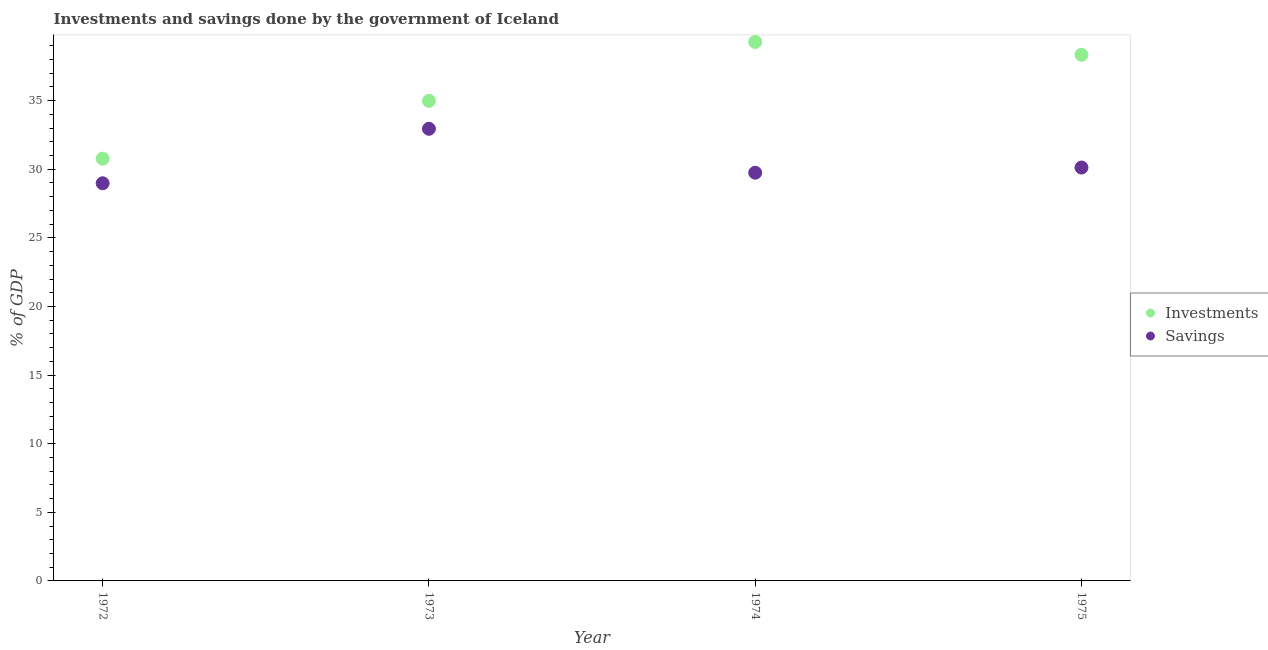Is the number of dotlines equal to the number of legend labels?
Your answer should be compact. Yes. What is the investments of government in 1974?
Provide a succinct answer. 39.28. Across all years, what is the maximum investments of government?
Ensure brevity in your answer.  39.28. Across all years, what is the minimum savings of government?
Offer a terse response. 28.98. In which year was the investments of government maximum?
Provide a succinct answer. 1974. In which year was the investments of government minimum?
Your response must be concise. 1972. What is the total savings of government in the graph?
Offer a terse response. 121.8. What is the difference between the investments of government in 1972 and that in 1973?
Provide a succinct answer. -4.21. What is the difference between the investments of government in 1975 and the savings of government in 1972?
Your answer should be compact. 9.36. What is the average savings of government per year?
Ensure brevity in your answer.  30.45. In the year 1974, what is the difference between the savings of government and investments of government?
Your response must be concise. -9.53. In how many years, is the savings of government greater than 6 %?
Your answer should be very brief. 4. What is the ratio of the investments of government in 1973 to that in 1974?
Give a very brief answer. 0.89. What is the difference between the highest and the second highest savings of government?
Keep it short and to the point. 2.82. What is the difference between the highest and the lowest investments of government?
Ensure brevity in your answer.  8.51. Is the sum of the investments of government in 1973 and 1975 greater than the maximum savings of government across all years?
Offer a terse response. Yes. Is the investments of government strictly greater than the savings of government over the years?
Your response must be concise. Yes. Is the investments of government strictly less than the savings of government over the years?
Make the answer very short. No. How many dotlines are there?
Your answer should be compact. 2. How many years are there in the graph?
Your answer should be compact. 4. Are the values on the major ticks of Y-axis written in scientific E-notation?
Your response must be concise. No. Does the graph contain any zero values?
Offer a very short reply. No. How many legend labels are there?
Your response must be concise. 2. What is the title of the graph?
Your response must be concise. Investments and savings done by the government of Iceland. What is the label or title of the Y-axis?
Keep it short and to the point. % of GDP. What is the % of GDP in Investments in 1972?
Offer a terse response. 30.77. What is the % of GDP in Savings in 1972?
Offer a terse response. 28.98. What is the % of GDP in Investments in 1973?
Give a very brief answer. 34.98. What is the % of GDP in Savings in 1973?
Keep it short and to the point. 32.95. What is the % of GDP in Investments in 1974?
Ensure brevity in your answer.  39.28. What is the % of GDP of Savings in 1974?
Your answer should be very brief. 29.75. What is the % of GDP of Investments in 1975?
Offer a very short reply. 38.34. What is the % of GDP of Savings in 1975?
Make the answer very short. 30.12. Across all years, what is the maximum % of GDP of Investments?
Your answer should be compact. 39.28. Across all years, what is the maximum % of GDP in Savings?
Offer a terse response. 32.95. Across all years, what is the minimum % of GDP in Investments?
Keep it short and to the point. 30.77. Across all years, what is the minimum % of GDP of Savings?
Offer a very short reply. 28.98. What is the total % of GDP of Investments in the graph?
Offer a very short reply. 143.37. What is the total % of GDP of Savings in the graph?
Keep it short and to the point. 121.8. What is the difference between the % of GDP in Investments in 1972 and that in 1973?
Your response must be concise. -4.21. What is the difference between the % of GDP in Savings in 1972 and that in 1973?
Give a very brief answer. -3.97. What is the difference between the % of GDP in Investments in 1972 and that in 1974?
Keep it short and to the point. -8.51. What is the difference between the % of GDP of Savings in 1972 and that in 1974?
Offer a very short reply. -0.77. What is the difference between the % of GDP in Investments in 1972 and that in 1975?
Keep it short and to the point. -7.57. What is the difference between the % of GDP of Savings in 1972 and that in 1975?
Make the answer very short. -1.15. What is the difference between the % of GDP of Investments in 1973 and that in 1974?
Your response must be concise. -4.29. What is the difference between the % of GDP in Savings in 1973 and that in 1974?
Offer a very short reply. 3.2. What is the difference between the % of GDP in Investments in 1973 and that in 1975?
Your answer should be compact. -3.36. What is the difference between the % of GDP in Savings in 1973 and that in 1975?
Your answer should be compact. 2.82. What is the difference between the % of GDP in Investments in 1974 and that in 1975?
Your response must be concise. 0.94. What is the difference between the % of GDP of Savings in 1974 and that in 1975?
Make the answer very short. -0.38. What is the difference between the % of GDP in Investments in 1972 and the % of GDP in Savings in 1973?
Offer a terse response. -2.18. What is the difference between the % of GDP in Investments in 1972 and the % of GDP in Savings in 1974?
Provide a succinct answer. 1.02. What is the difference between the % of GDP in Investments in 1972 and the % of GDP in Savings in 1975?
Give a very brief answer. 0.65. What is the difference between the % of GDP in Investments in 1973 and the % of GDP in Savings in 1974?
Your answer should be very brief. 5.24. What is the difference between the % of GDP in Investments in 1973 and the % of GDP in Savings in 1975?
Ensure brevity in your answer.  4.86. What is the difference between the % of GDP of Investments in 1974 and the % of GDP of Savings in 1975?
Provide a short and direct response. 9.15. What is the average % of GDP in Investments per year?
Give a very brief answer. 35.84. What is the average % of GDP in Savings per year?
Give a very brief answer. 30.45. In the year 1972, what is the difference between the % of GDP in Investments and % of GDP in Savings?
Provide a short and direct response. 1.79. In the year 1973, what is the difference between the % of GDP of Investments and % of GDP of Savings?
Your response must be concise. 2.03. In the year 1974, what is the difference between the % of GDP in Investments and % of GDP in Savings?
Ensure brevity in your answer.  9.53. In the year 1975, what is the difference between the % of GDP in Investments and % of GDP in Savings?
Offer a terse response. 8.22. What is the ratio of the % of GDP of Investments in 1972 to that in 1973?
Provide a short and direct response. 0.88. What is the ratio of the % of GDP in Savings in 1972 to that in 1973?
Make the answer very short. 0.88. What is the ratio of the % of GDP of Investments in 1972 to that in 1974?
Your response must be concise. 0.78. What is the ratio of the % of GDP of Savings in 1972 to that in 1974?
Offer a terse response. 0.97. What is the ratio of the % of GDP of Investments in 1972 to that in 1975?
Offer a very short reply. 0.8. What is the ratio of the % of GDP in Savings in 1972 to that in 1975?
Provide a short and direct response. 0.96. What is the ratio of the % of GDP of Investments in 1973 to that in 1974?
Give a very brief answer. 0.89. What is the ratio of the % of GDP of Savings in 1973 to that in 1974?
Keep it short and to the point. 1.11. What is the ratio of the % of GDP of Investments in 1973 to that in 1975?
Keep it short and to the point. 0.91. What is the ratio of the % of GDP in Savings in 1973 to that in 1975?
Your answer should be very brief. 1.09. What is the ratio of the % of GDP of Investments in 1974 to that in 1975?
Your response must be concise. 1.02. What is the ratio of the % of GDP in Savings in 1974 to that in 1975?
Keep it short and to the point. 0.99. What is the difference between the highest and the second highest % of GDP in Investments?
Your answer should be very brief. 0.94. What is the difference between the highest and the second highest % of GDP in Savings?
Your answer should be compact. 2.82. What is the difference between the highest and the lowest % of GDP in Investments?
Your answer should be compact. 8.51. What is the difference between the highest and the lowest % of GDP of Savings?
Your answer should be very brief. 3.97. 